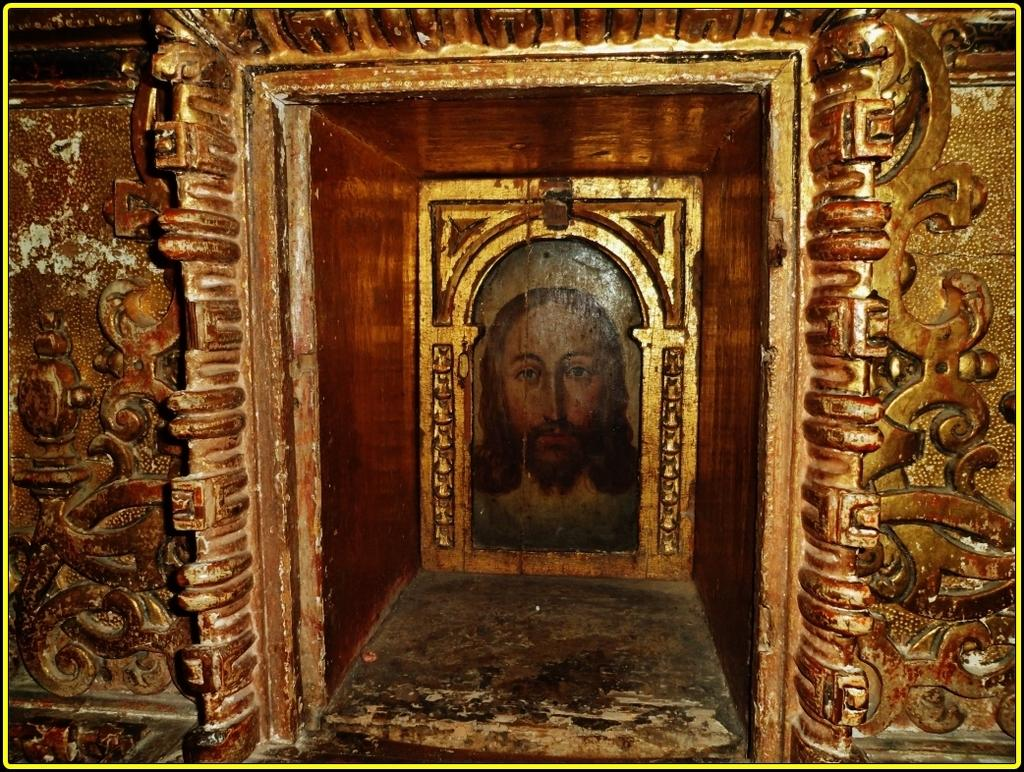What is depicted on the wall in the image? There is a wall with carvings in the image. What type of space is shown in the image? There is a small room in the image. What can be seen inside the small room? There is a painting of Jesus in the small room. What time of day is depicted in the image? The time of day is not depicted in the image; there is no indication of the time. What type of furniture is present in the small room? The provided facts do not mention any furniture in the small room. 